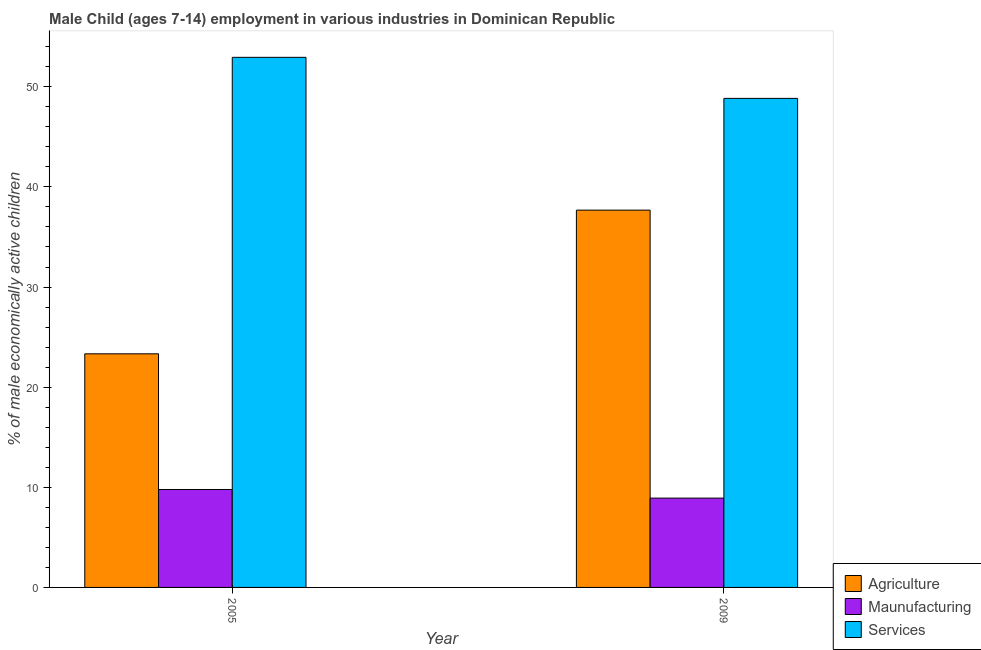How many groups of bars are there?
Provide a short and direct response. 2. Are the number of bars on each tick of the X-axis equal?
Your response must be concise. Yes. How many bars are there on the 2nd tick from the left?
Provide a short and direct response. 3. How many bars are there on the 2nd tick from the right?
Give a very brief answer. 3. In how many cases, is the number of bars for a given year not equal to the number of legend labels?
Offer a terse response. 0. What is the percentage of economically active children in manufacturing in 2005?
Provide a succinct answer. 9.78. Across all years, what is the maximum percentage of economically active children in services?
Your response must be concise. 52.94. Across all years, what is the minimum percentage of economically active children in services?
Your answer should be compact. 48.84. What is the total percentage of economically active children in services in the graph?
Keep it short and to the point. 101.78. What is the difference between the percentage of economically active children in agriculture in 2005 and that in 2009?
Your response must be concise. -14.35. What is the difference between the percentage of economically active children in agriculture in 2009 and the percentage of economically active children in services in 2005?
Provide a succinct answer. 14.35. What is the average percentage of economically active children in agriculture per year?
Offer a very short reply. 30.5. In the year 2009, what is the difference between the percentage of economically active children in manufacturing and percentage of economically active children in services?
Keep it short and to the point. 0. What is the ratio of the percentage of economically active children in agriculture in 2005 to that in 2009?
Give a very brief answer. 0.62. What does the 2nd bar from the left in 2009 represents?
Provide a succinct answer. Maunufacturing. What does the 2nd bar from the right in 2005 represents?
Your response must be concise. Maunufacturing. How many years are there in the graph?
Offer a very short reply. 2. Are the values on the major ticks of Y-axis written in scientific E-notation?
Ensure brevity in your answer.  No. Where does the legend appear in the graph?
Provide a succinct answer. Bottom right. How many legend labels are there?
Offer a very short reply. 3. What is the title of the graph?
Your answer should be very brief. Male Child (ages 7-14) employment in various industries in Dominican Republic. Does "Taxes on income" appear as one of the legend labels in the graph?
Keep it short and to the point. No. What is the label or title of the Y-axis?
Offer a terse response. % of male economically active children. What is the % of male economically active children of Agriculture in 2005?
Make the answer very short. 23.33. What is the % of male economically active children of Maunufacturing in 2005?
Keep it short and to the point. 9.78. What is the % of male economically active children in Services in 2005?
Your answer should be very brief. 52.94. What is the % of male economically active children in Agriculture in 2009?
Keep it short and to the point. 37.68. What is the % of male economically active children of Maunufacturing in 2009?
Your response must be concise. 8.92. What is the % of male economically active children of Services in 2009?
Your answer should be very brief. 48.84. Across all years, what is the maximum % of male economically active children in Agriculture?
Ensure brevity in your answer.  37.68. Across all years, what is the maximum % of male economically active children in Maunufacturing?
Ensure brevity in your answer.  9.78. Across all years, what is the maximum % of male economically active children of Services?
Provide a short and direct response. 52.94. Across all years, what is the minimum % of male economically active children of Agriculture?
Keep it short and to the point. 23.33. Across all years, what is the minimum % of male economically active children in Maunufacturing?
Give a very brief answer. 8.92. Across all years, what is the minimum % of male economically active children in Services?
Provide a succinct answer. 48.84. What is the total % of male economically active children in Agriculture in the graph?
Give a very brief answer. 61.01. What is the total % of male economically active children in Services in the graph?
Keep it short and to the point. 101.78. What is the difference between the % of male economically active children of Agriculture in 2005 and that in 2009?
Provide a short and direct response. -14.35. What is the difference between the % of male economically active children of Maunufacturing in 2005 and that in 2009?
Offer a very short reply. 0.86. What is the difference between the % of male economically active children of Services in 2005 and that in 2009?
Offer a very short reply. 4.1. What is the difference between the % of male economically active children in Agriculture in 2005 and the % of male economically active children in Maunufacturing in 2009?
Offer a terse response. 14.41. What is the difference between the % of male economically active children in Agriculture in 2005 and the % of male economically active children in Services in 2009?
Offer a very short reply. -25.51. What is the difference between the % of male economically active children of Maunufacturing in 2005 and the % of male economically active children of Services in 2009?
Provide a short and direct response. -39.06. What is the average % of male economically active children of Agriculture per year?
Offer a terse response. 30.5. What is the average % of male economically active children in Maunufacturing per year?
Keep it short and to the point. 9.35. What is the average % of male economically active children in Services per year?
Ensure brevity in your answer.  50.89. In the year 2005, what is the difference between the % of male economically active children of Agriculture and % of male economically active children of Maunufacturing?
Ensure brevity in your answer.  13.55. In the year 2005, what is the difference between the % of male economically active children in Agriculture and % of male economically active children in Services?
Your answer should be very brief. -29.61. In the year 2005, what is the difference between the % of male economically active children of Maunufacturing and % of male economically active children of Services?
Provide a short and direct response. -43.16. In the year 2009, what is the difference between the % of male economically active children in Agriculture and % of male economically active children in Maunufacturing?
Your response must be concise. 28.76. In the year 2009, what is the difference between the % of male economically active children of Agriculture and % of male economically active children of Services?
Keep it short and to the point. -11.16. In the year 2009, what is the difference between the % of male economically active children of Maunufacturing and % of male economically active children of Services?
Your response must be concise. -39.92. What is the ratio of the % of male economically active children of Agriculture in 2005 to that in 2009?
Make the answer very short. 0.62. What is the ratio of the % of male economically active children of Maunufacturing in 2005 to that in 2009?
Offer a very short reply. 1.1. What is the ratio of the % of male economically active children in Services in 2005 to that in 2009?
Give a very brief answer. 1.08. What is the difference between the highest and the second highest % of male economically active children in Agriculture?
Make the answer very short. 14.35. What is the difference between the highest and the second highest % of male economically active children of Maunufacturing?
Offer a very short reply. 0.86. What is the difference between the highest and the lowest % of male economically active children of Agriculture?
Give a very brief answer. 14.35. What is the difference between the highest and the lowest % of male economically active children of Maunufacturing?
Make the answer very short. 0.86. What is the difference between the highest and the lowest % of male economically active children of Services?
Give a very brief answer. 4.1. 